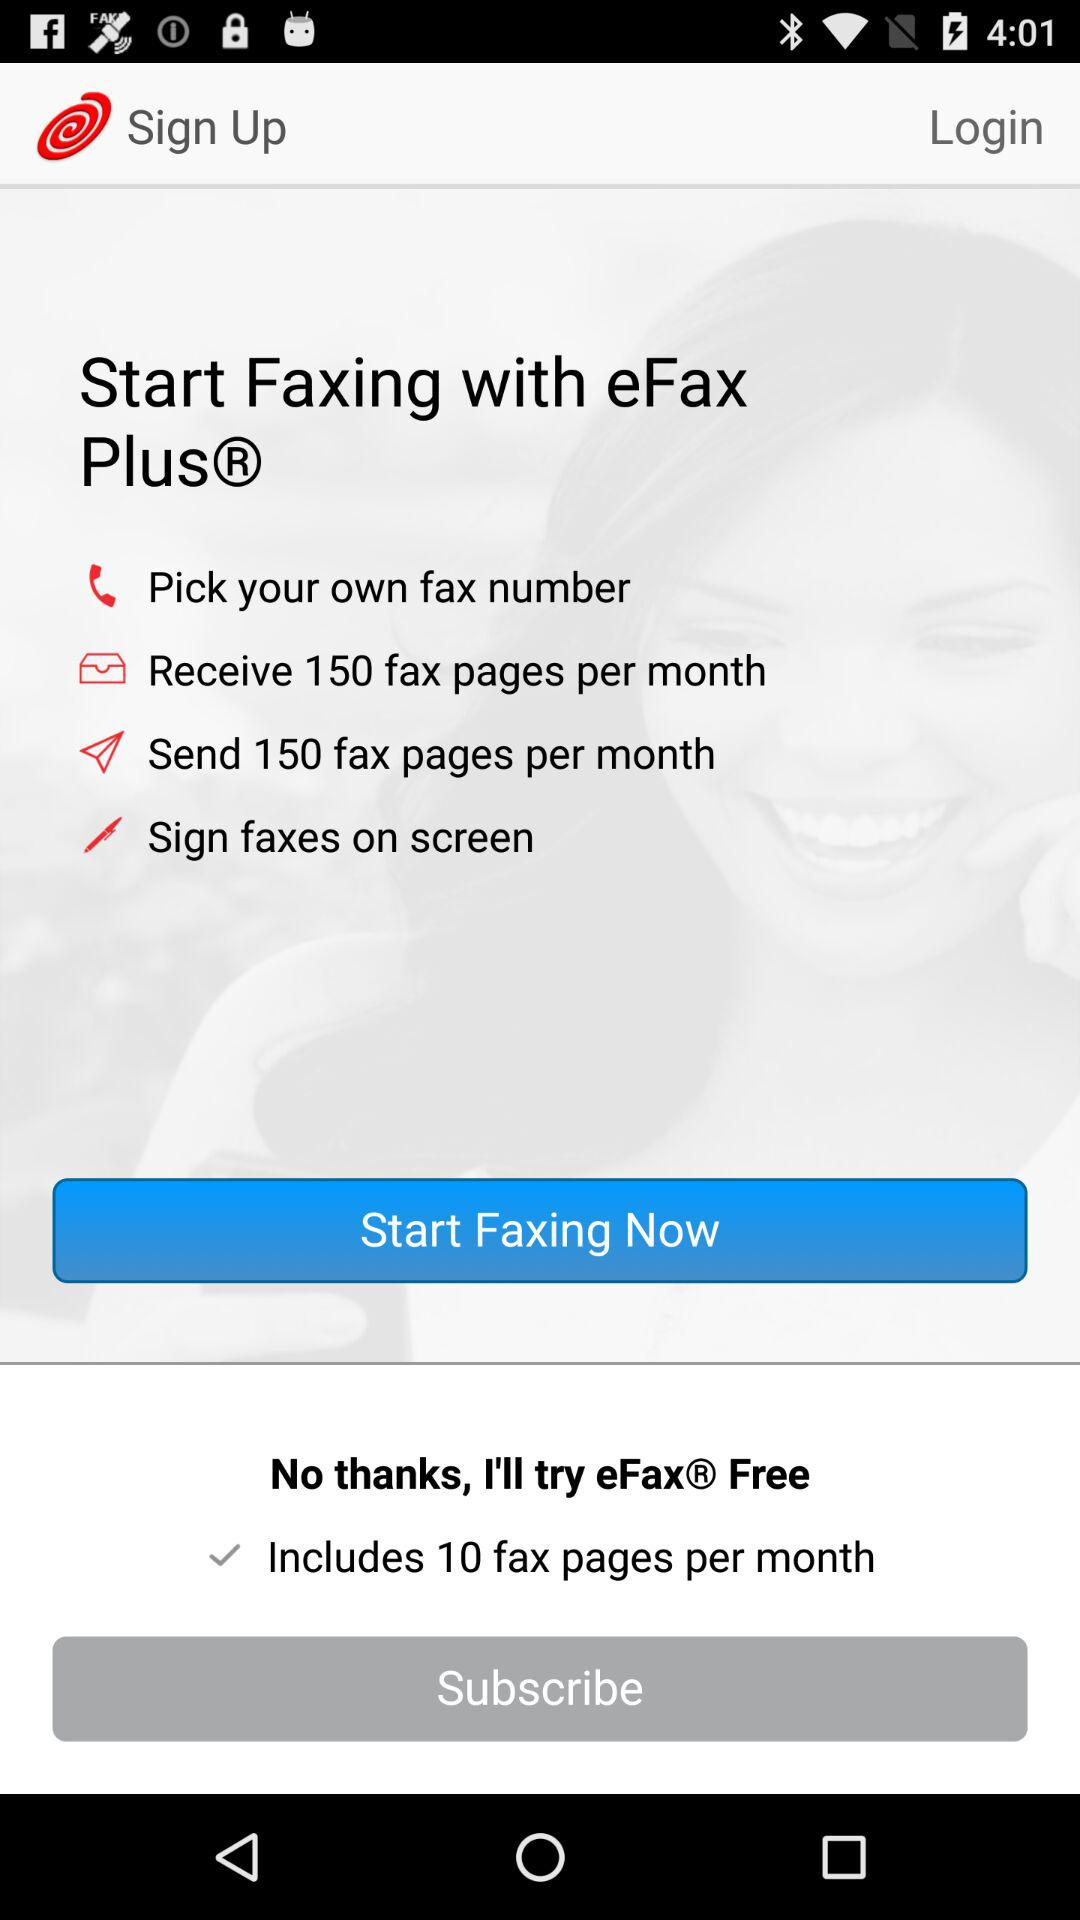What is the name of the application? The name of the application is "eFax". 